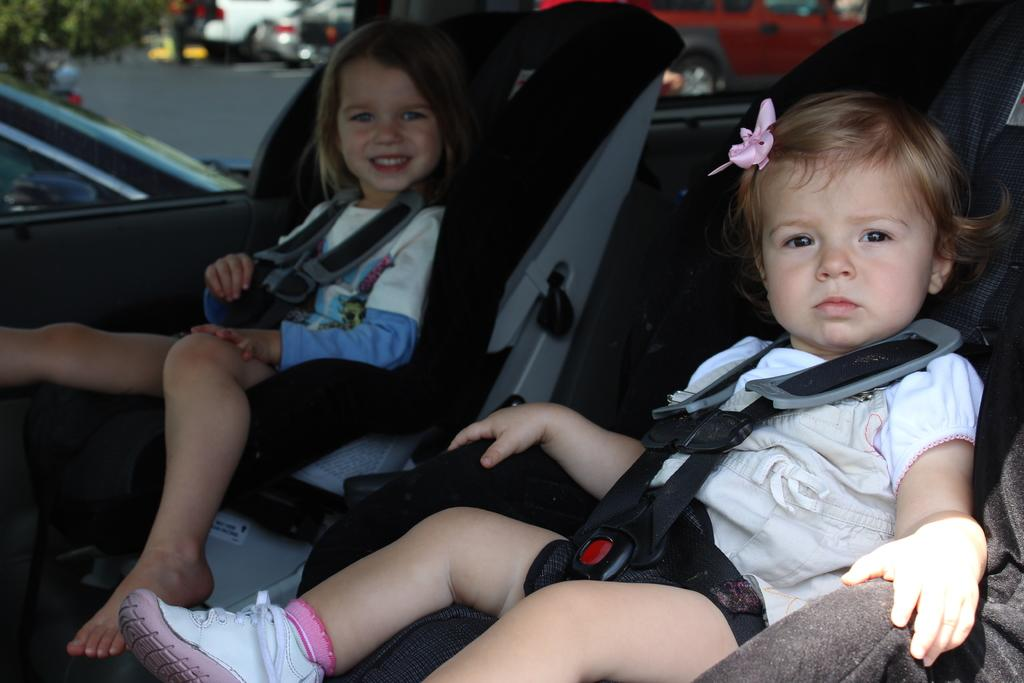How many kids are in the image? There are two kids in the image. What are the kids doing in the image? The kids are seated on a chair. What can be seen in the background of the image? There are cars and a tree visible in the background of the image. What type of hill can be seen in the image? There is no hill present in the image. What season is depicted in the image? The provided facts do not mention any seasonal details, so it cannot be determined from the image. 